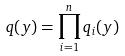<formula> <loc_0><loc_0><loc_500><loc_500>q ( y ) = \prod _ { i = 1 } ^ { n } q _ { i } ( y )</formula> 